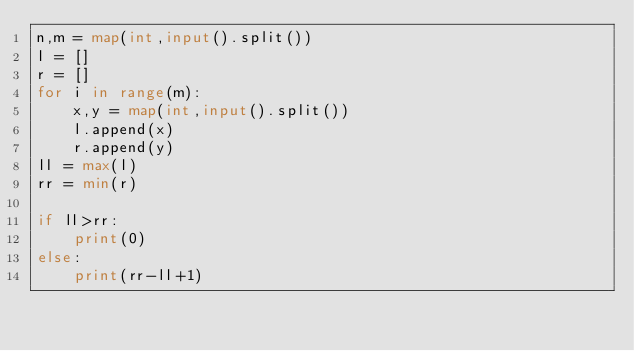<code> <loc_0><loc_0><loc_500><loc_500><_Python_>n,m = map(int,input().split())
l = []
r = []
for i in range(m):
    x,y = map(int,input().split())
    l.append(x)
    r.append(y)
ll = max(l)
rr = min(r)

if ll>rr:
    print(0)
else:
    print(rr-ll+1)
</code> 